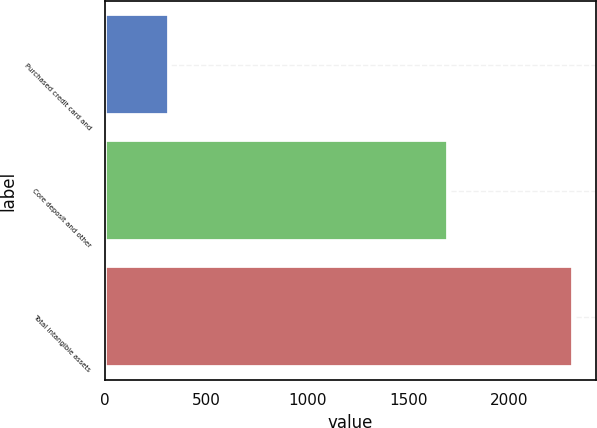Convert chart to OTSL. <chart><loc_0><loc_0><loc_500><loc_500><bar_chart><fcel>Purchased credit card and<fcel>Core deposit and other<fcel>Total intangible assets<nl><fcel>315<fcel>1695<fcel>2312<nl></chart> 